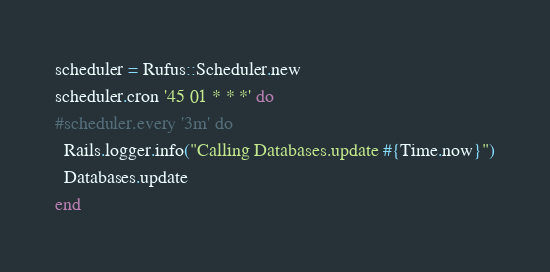<code> <loc_0><loc_0><loc_500><loc_500><_Ruby_>scheduler = Rufus::Scheduler.new
scheduler.cron '45 01 * * *' do
#scheduler.every '3m' do
  Rails.logger.info("Calling Databases.update #{Time.now}")
  Databases.update
end
</code> 